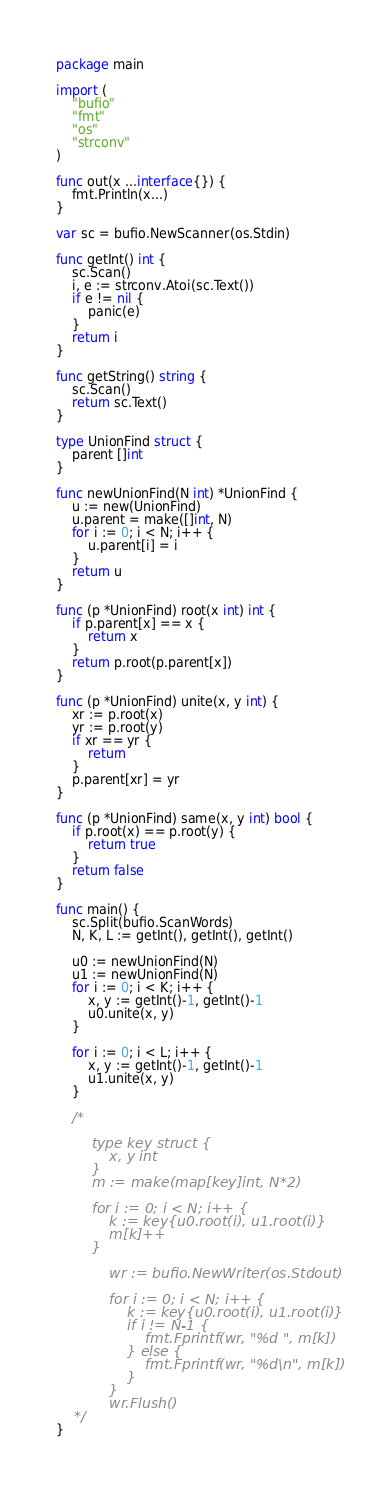Convert code to text. <code><loc_0><loc_0><loc_500><loc_500><_Go_>package main

import (
	"bufio"
	"fmt"
	"os"
	"strconv"
)

func out(x ...interface{}) {
	fmt.Println(x...)
}

var sc = bufio.NewScanner(os.Stdin)

func getInt() int {
	sc.Scan()
	i, e := strconv.Atoi(sc.Text())
	if e != nil {
		panic(e)
	}
	return i
}

func getString() string {
	sc.Scan()
	return sc.Text()
}

type UnionFind struct {
	parent []int
}

func newUnionFind(N int) *UnionFind {
	u := new(UnionFind)
	u.parent = make([]int, N)
	for i := 0; i < N; i++ {
		u.parent[i] = i
	}
	return u
}

func (p *UnionFind) root(x int) int {
	if p.parent[x] == x {
		return x
	}
	return p.root(p.parent[x])
}

func (p *UnionFind) unite(x, y int) {
	xr := p.root(x)
	yr := p.root(y)
	if xr == yr {
		return
	}
	p.parent[xr] = yr
}

func (p *UnionFind) same(x, y int) bool {
	if p.root(x) == p.root(y) {
		return true
	}
	return false
}

func main() {
	sc.Split(bufio.ScanWords)
	N, K, L := getInt(), getInt(), getInt()

	u0 := newUnionFind(N)
	u1 := newUnionFind(N)
	for i := 0; i < K; i++ {
		x, y := getInt()-1, getInt()-1
		u0.unite(x, y)
	}

	for i := 0; i < L; i++ {
		x, y := getInt()-1, getInt()-1
		u1.unite(x, y)
	}

	/*

		type key struct {
			x, y int
		}
		m := make(map[key]int, N*2)

		for i := 0; i < N; i++ {
			k := key{u0.root(i), u1.root(i)}
			m[k]++
		}

			wr := bufio.NewWriter(os.Stdout)

			for i := 0; i < N; i++ {
				k := key{u0.root(i), u1.root(i)}
				if i != N-1 {
					fmt.Fprintf(wr, "%d ", m[k])
				} else {
					fmt.Fprintf(wr, "%d\n", m[k])
				}
			}
			wr.Flush()
	*/
}
</code> 